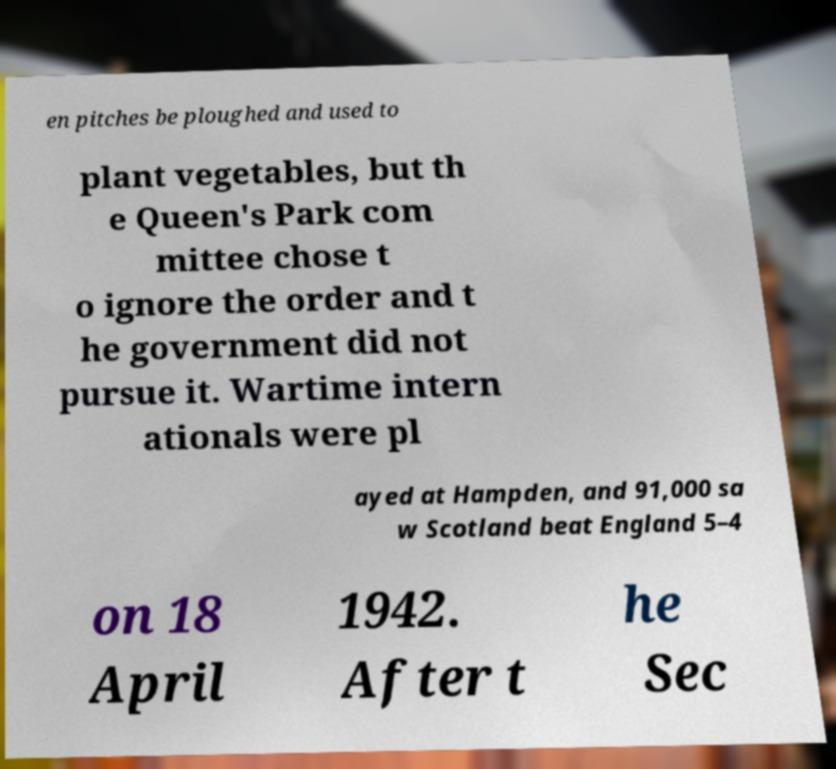Can you accurately transcribe the text from the provided image for me? en pitches be ploughed and used to plant vegetables, but th e Queen's Park com mittee chose t o ignore the order and t he government did not pursue it. Wartime intern ationals were pl ayed at Hampden, and 91,000 sa w Scotland beat England 5–4 on 18 April 1942. After t he Sec 